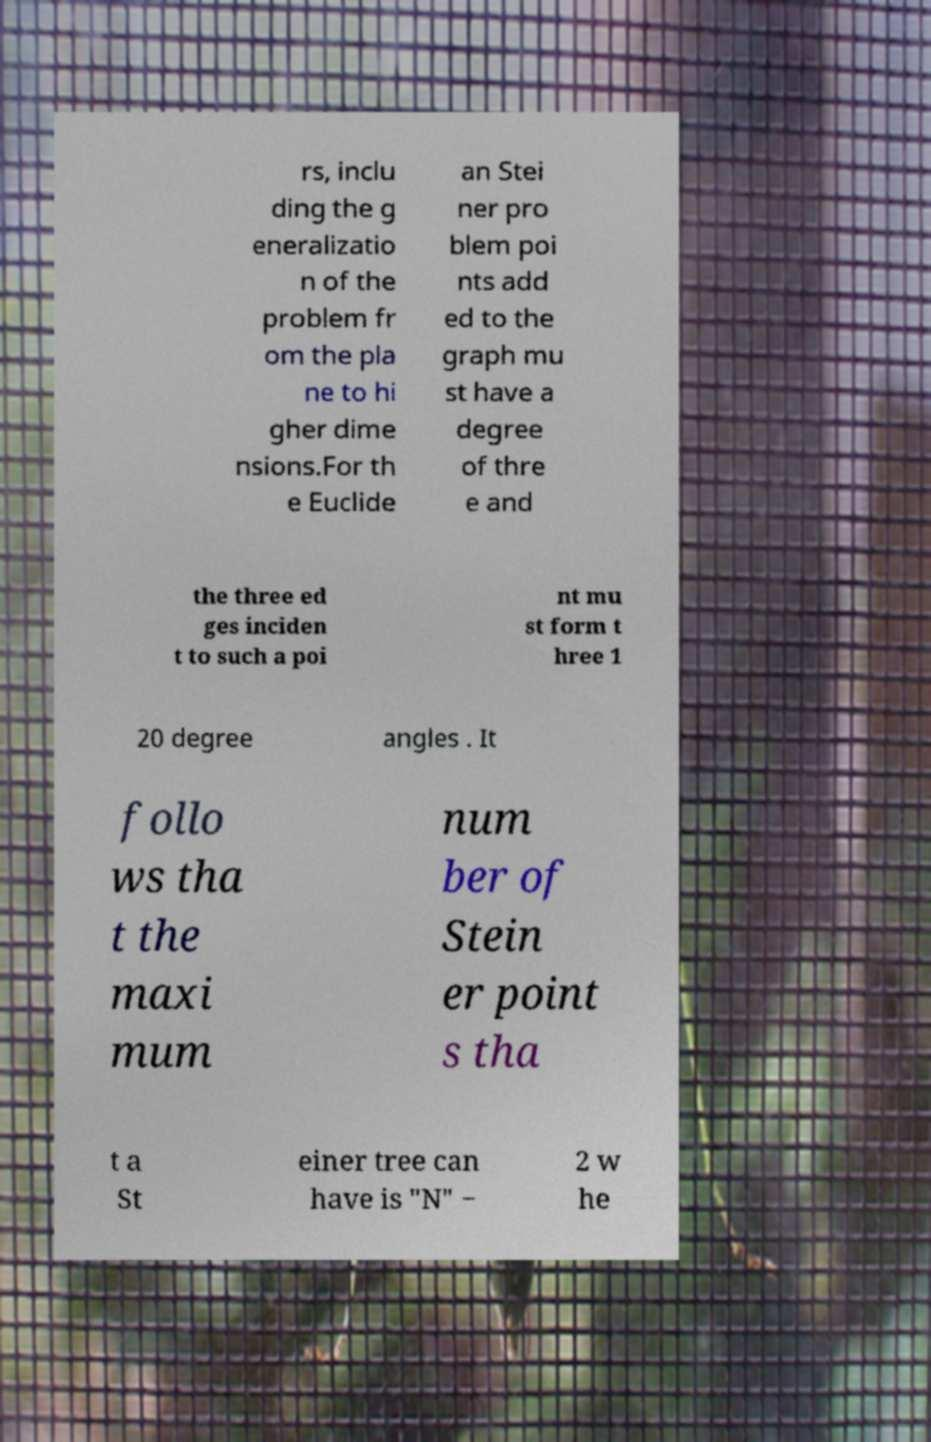There's text embedded in this image that I need extracted. Can you transcribe it verbatim? rs, inclu ding the g eneralizatio n of the problem fr om the pla ne to hi gher dime nsions.For th e Euclide an Stei ner pro blem poi nts add ed to the graph mu st have a degree of thre e and the three ed ges inciden t to such a poi nt mu st form t hree 1 20 degree angles . It follo ws tha t the maxi mum num ber of Stein er point s tha t a St einer tree can have is "N" − 2 w he 